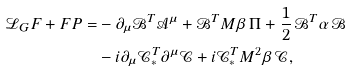<formula> <loc_0><loc_0><loc_500><loc_500>\mathcal { L } _ { G } F + F P = & - \partial _ { \mu } \mathcal { B } ^ { T } \mathcal { A } ^ { \mu } + { \mathcal { B } } ^ { T } M { \beta } \, \Pi + \frac { 1 } { 2 } \, \mathcal { B } ^ { T } { \alpha } \, \mathcal { B } \\ & - i \partial _ { \mu } \mathcal { C } _ { * } ^ { T } \partial ^ { \mu } \mathcal { C } + i \mathcal { C } _ { * } ^ { T } M ^ { 2 } { \beta } \, \mathcal { C } ,</formula> 